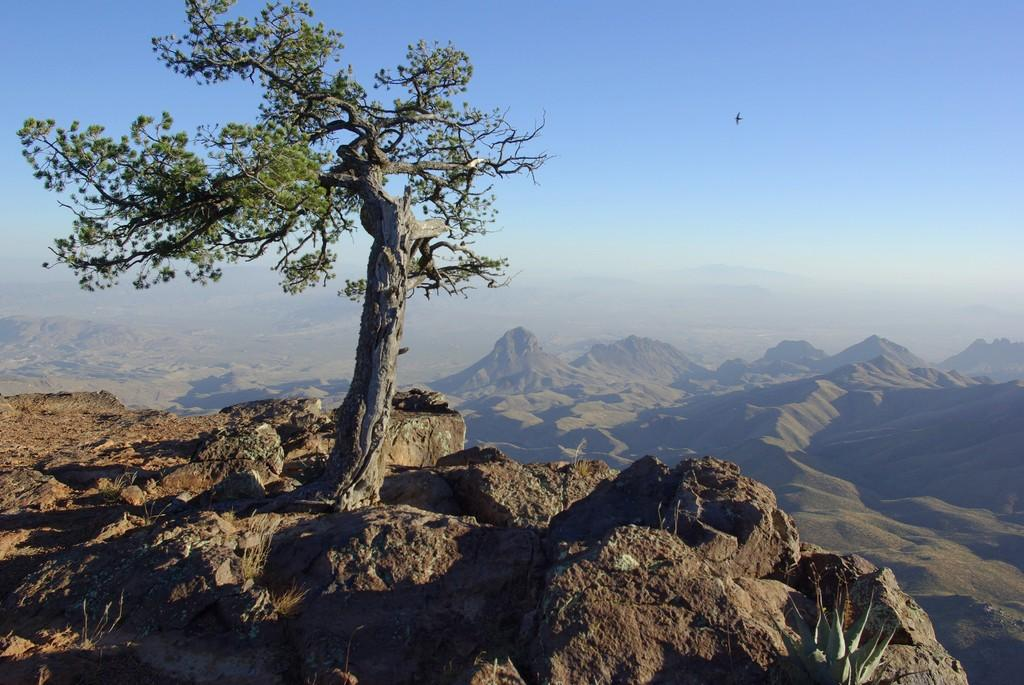What is located in the foreground of the image? There is a tree on a cliff in the foreground of the image. What can be seen in the background of the image? There are mountains and the sky visible in the background of the image. Can you describe the bird in the image? There is a bird in the air in the background of the image. What type of drawer can be seen in the image? There is no drawer present in the image. How does the taste of the mountains compare to the taste of the sky in the image? The mountains and sky are not edible, so they cannot be tasted. 